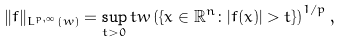<formula> <loc_0><loc_0><loc_500><loc_500>\| f \| _ { L ^ { p , \infty } ( w ) } & = \sup _ { t > 0 } t w \left ( \{ x \in \mathbb { R } ^ { n } \colon | f ( x ) | > t \} \right ) ^ { 1 / p } ,</formula> 